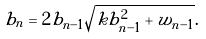<formula> <loc_0><loc_0><loc_500><loc_500>b _ { n } = 2 b _ { n - 1 } \sqrt { k b _ { n - 1 } ^ { 2 } + w _ { n - 1 } } .</formula> 